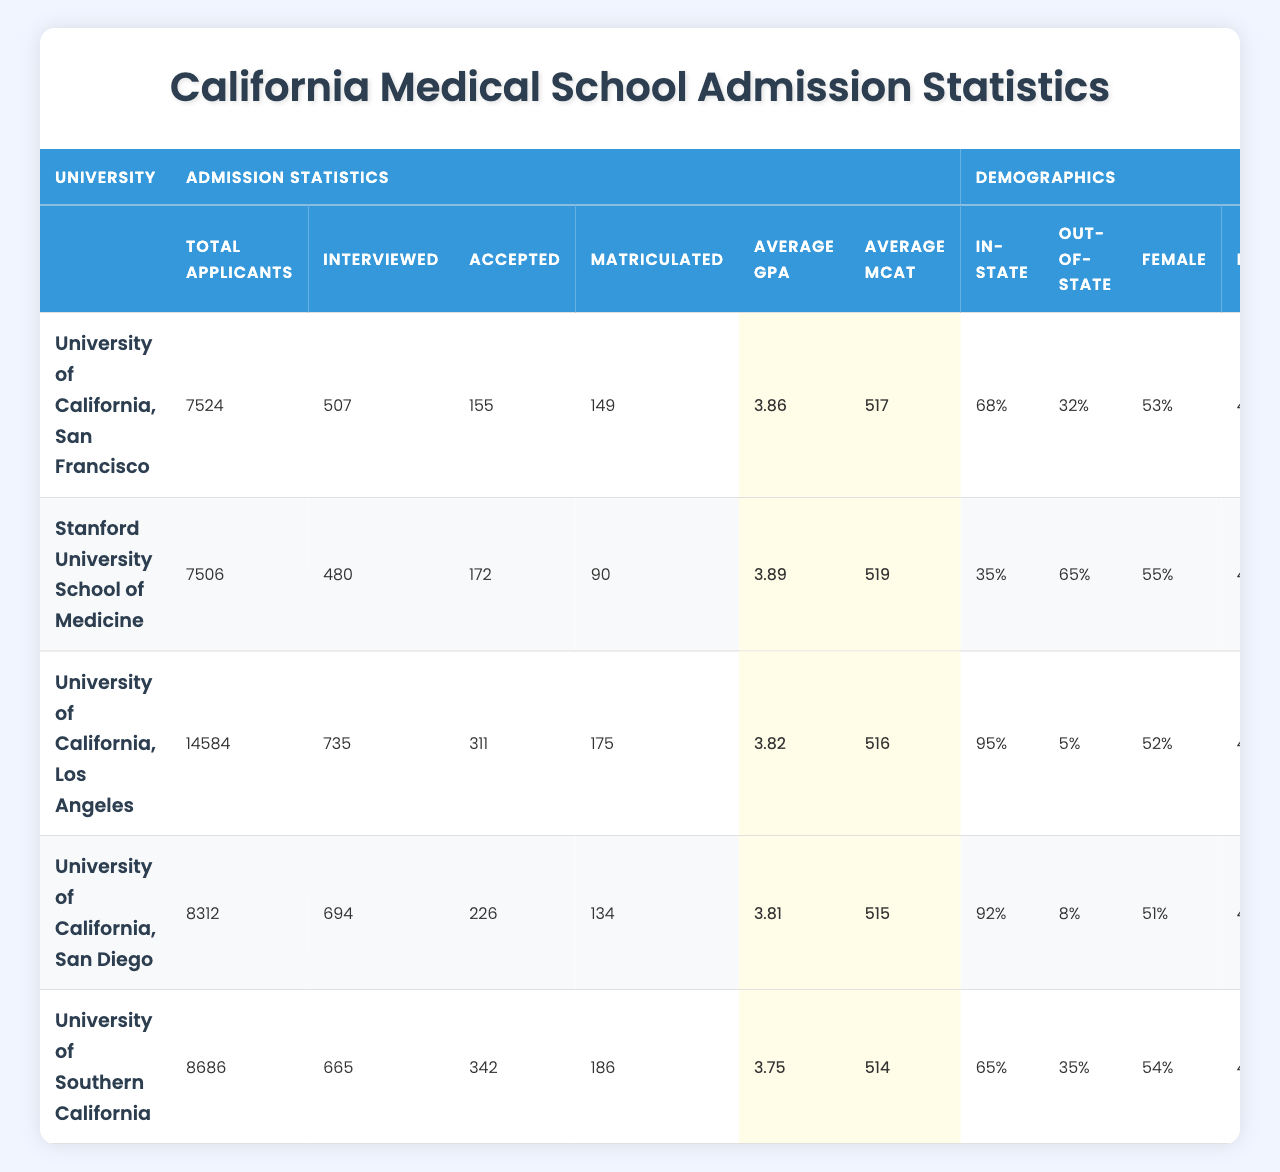What is the total number of applicants for the University of California, Los Angeles? The table lists the total applicants for each university, and for UCLA, it shows 14,584 applicants.
Answer: 14,584 How many students were accepted at Stanford University School of Medicine? The table indicates that Stanford University had 172 students accepted.
Answer: 172 Which university has the highest average GPA? According to the average GPA statistics in the table, Stanford University has the highest average GPA of 3.89.
Answer: Stanford University What percentage of applicants were interviewed at the University of California, San Diego? To find the percentage of applicants interviewed, divide the number interviewed (694) by the total applicants (8,312) and multiply by 100. (694 / 8312) * 100 ≈ 8.34%.
Answer: Approximately 8.34% Which university has the highest percentage of in-state students? By comparing the in-state percentages in the demographics section, the University of California, Los Angeles has 95%, which is the highest.
Answer: University of California, Los Angeles What is the difference in the average MCAT scores between the University of California, San Francisco and the University of Southern California? The average MCAT for UCSF is 517, and for USC, it is 514. The difference is calculated as 517 - 514 = 3.
Answer: 3 How many students matriculated at the University of California, San Francisco? The matriculated number for UCSF is shown as 149 students.
Answer: 149 Which university has a lower acceptance rate: University of California, San Diego or University of Southern California? First, calculate the acceptance rates: UCSD has 226 accepted out of 8,312 applicants (226/8312) ≈ 2.72%, while USC has 342 accepted from 8,686 applicants (342/8686) ≈ 3.93%. UCSD has a lower acceptance rate.
Answer: University of California, San Diego What is the total number of interviewed candidates across all universities listed? Adding the interviewed counts: 507 (UCSF) + 480 (Stanford) + 735 (UCLA) + 694 (UCSD) + 665 (USC) = 3081.
Answer: 3,081 Are there more females or males accepted at the University of California, San Diego? For UCSD, 51% of the total students admissions were females and 49% were males, indicating that there were more females accepted.
Answer: Females 